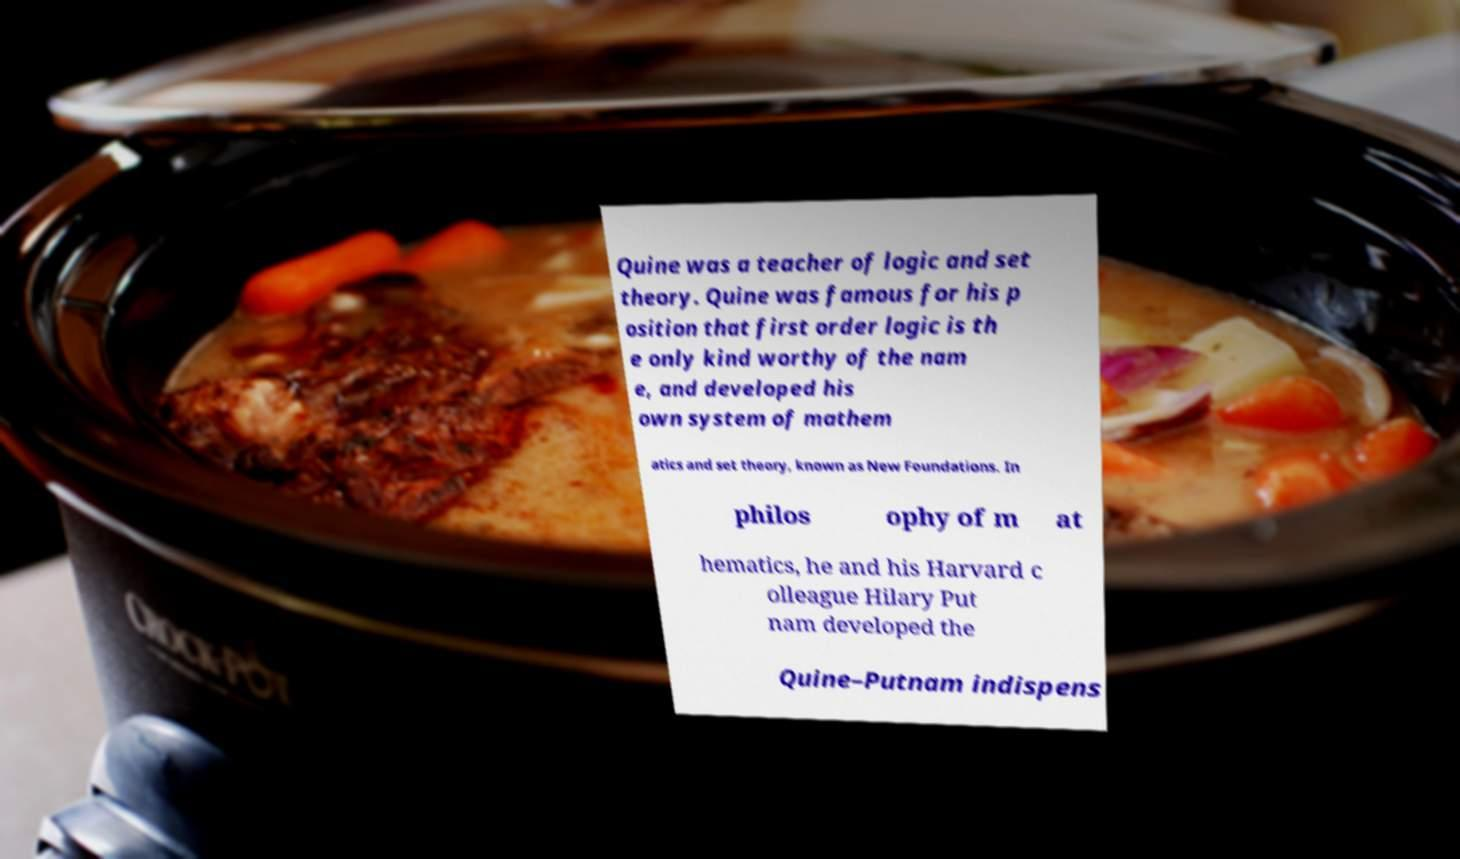Please read and relay the text visible in this image. What does it say? Quine was a teacher of logic and set theory. Quine was famous for his p osition that first order logic is th e only kind worthy of the nam e, and developed his own system of mathem atics and set theory, known as New Foundations. In philos ophy of m at hematics, he and his Harvard c olleague Hilary Put nam developed the Quine–Putnam indispens 